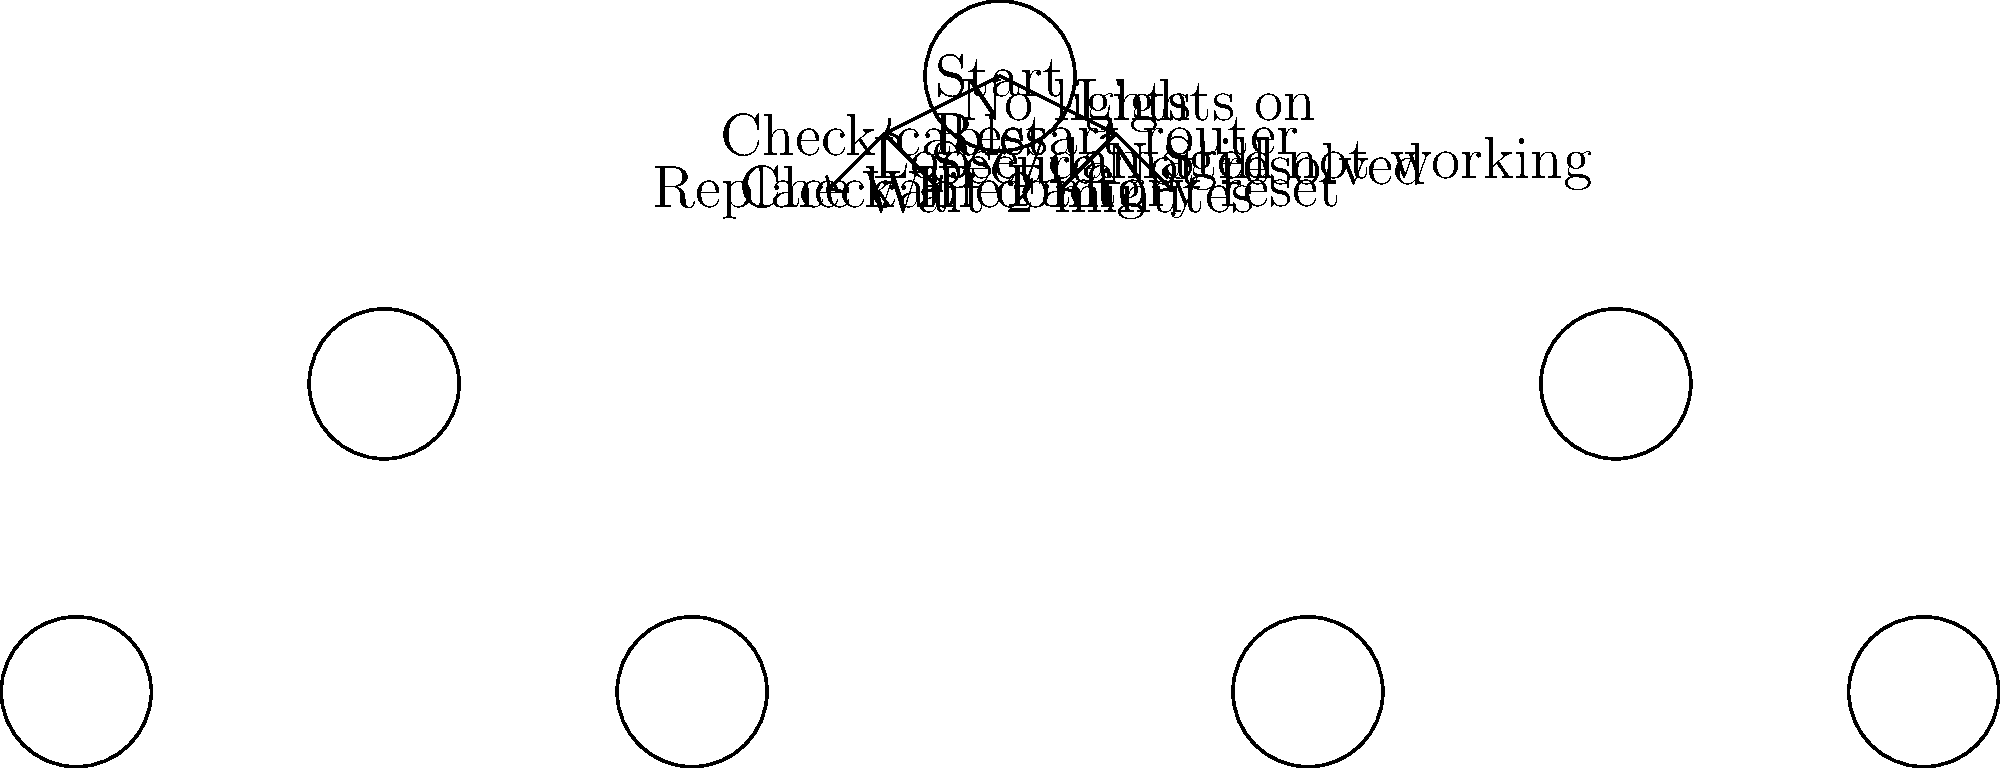As a former pilot now working in IT support, you're tasked with creating a decision tree for troubleshooting network connectivity issues. Based on the diagram, what is the first step if the router shows no lights? To answer this question, we need to follow the decision tree diagram from the start:

1. We begin at the "Start" node at the top of the diagram.
2. From the start, there are two paths: "No lights" and "Lights on".
3. Since the question asks about a scenario where the router shows no lights, we follow the "No lights" path.
4. This path leads directly to the "Check cables" node.

Therefore, according to the decision tree, if the router shows no lights, the first step in troubleshooting is to check the cables.

This approach is logical in network troubleshooting:
- If there are no lights on the router, it could indicate a power issue or disconnected cables.
- Checking the cables is a quick and easy first step that can often resolve simple connectivity problems.
- It's important to ensure all physical connections are secure before moving on to more complex troubleshooting steps.
Answer: Check cables 